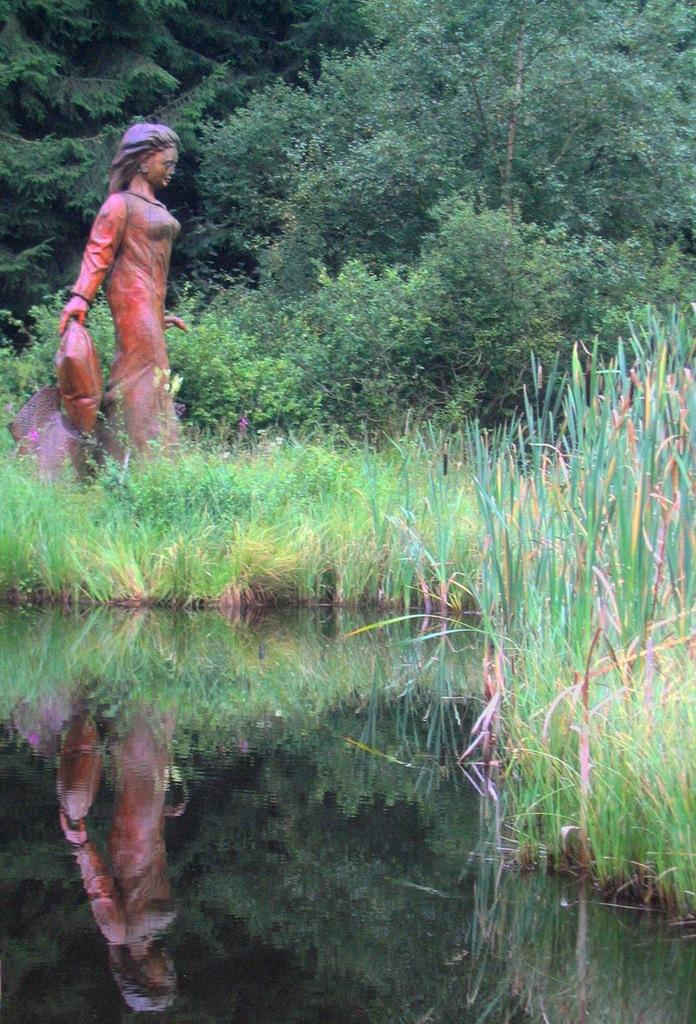What is the main subject of the image? There is a statue of a woman in the image. Where is the statue located? The statue is on grass. What type of vegetation is present in the image? There are trees and grass in the image. What body of water is visible in the image? There is a lake in the image. What can be seen reflected in the lake? There is a person's image visible in the lake. What type of sack is being used to make noise in the image? There is no sack or noise present in the image. What type of face can be seen on the statue in the image? The statue is of a woman, but the facts provided do not mention any specific facial features. 